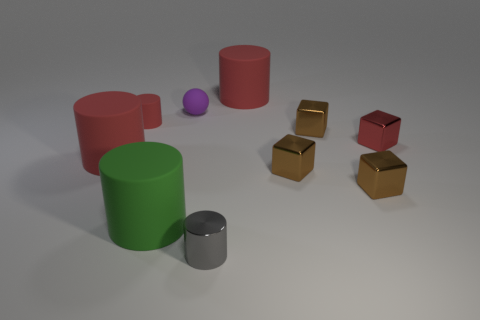Subtract all purple blocks. How many red cylinders are left? 3 Subtract all gray cylinders. How many cylinders are left? 4 Subtract all big green matte cylinders. How many cylinders are left? 4 Subtract all yellow cylinders. Subtract all gray spheres. How many cylinders are left? 5 Subtract all balls. How many objects are left? 9 Add 6 large red rubber things. How many large red rubber things exist? 8 Subtract 1 green cylinders. How many objects are left? 9 Subtract all small blue cubes. Subtract all small rubber balls. How many objects are left? 9 Add 2 small matte cylinders. How many small matte cylinders are left? 3 